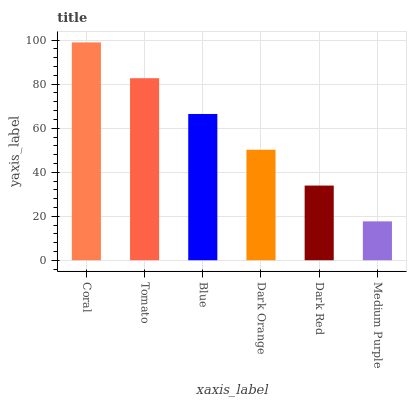Is Medium Purple the minimum?
Answer yes or no. Yes. Is Coral the maximum?
Answer yes or no. Yes. Is Tomato the minimum?
Answer yes or no. No. Is Tomato the maximum?
Answer yes or no. No. Is Coral greater than Tomato?
Answer yes or no. Yes. Is Tomato less than Coral?
Answer yes or no. Yes. Is Tomato greater than Coral?
Answer yes or no. No. Is Coral less than Tomato?
Answer yes or no. No. Is Blue the high median?
Answer yes or no. Yes. Is Dark Orange the low median?
Answer yes or no. Yes. Is Medium Purple the high median?
Answer yes or no. No. Is Blue the low median?
Answer yes or no. No. 